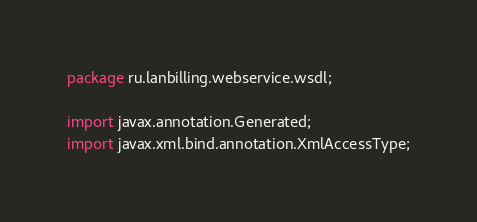Convert code to text. <code><loc_0><loc_0><loc_500><loc_500><_Java_>
package ru.lanbilling.webservice.wsdl;

import javax.annotation.Generated;
import javax.xml.bind.annotation.XmlAccessType;</code> 